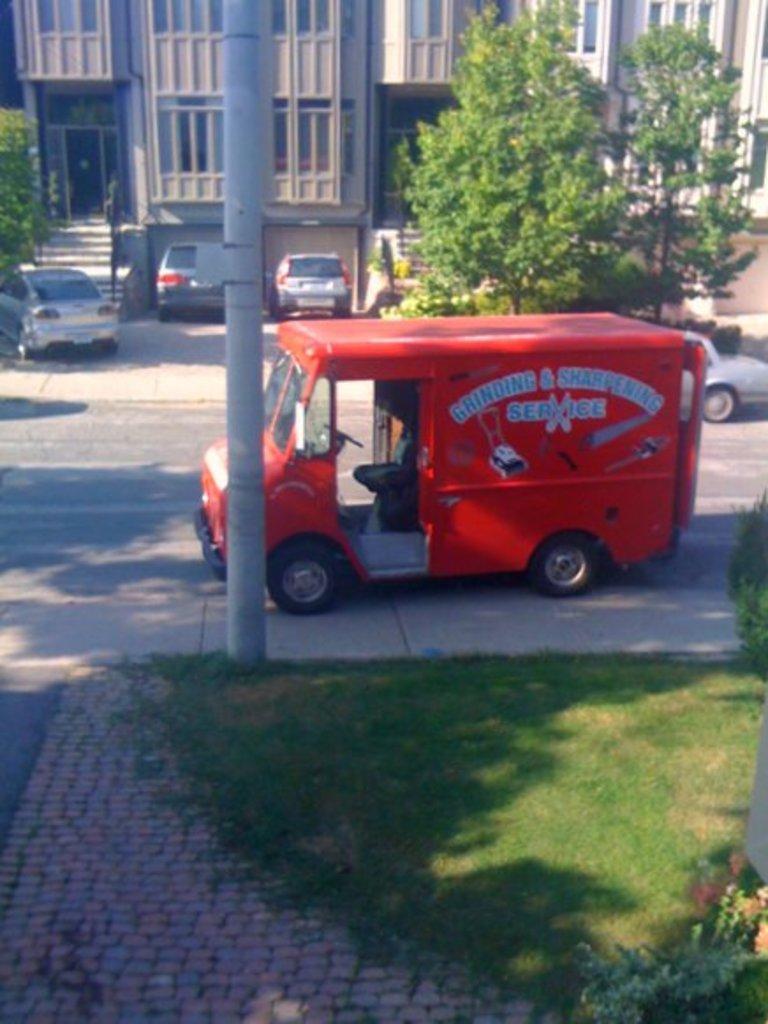Describe this image in one or two sentences. In this image, we can see vehicles on the road and in the background, there are trees, buildings, poles. 